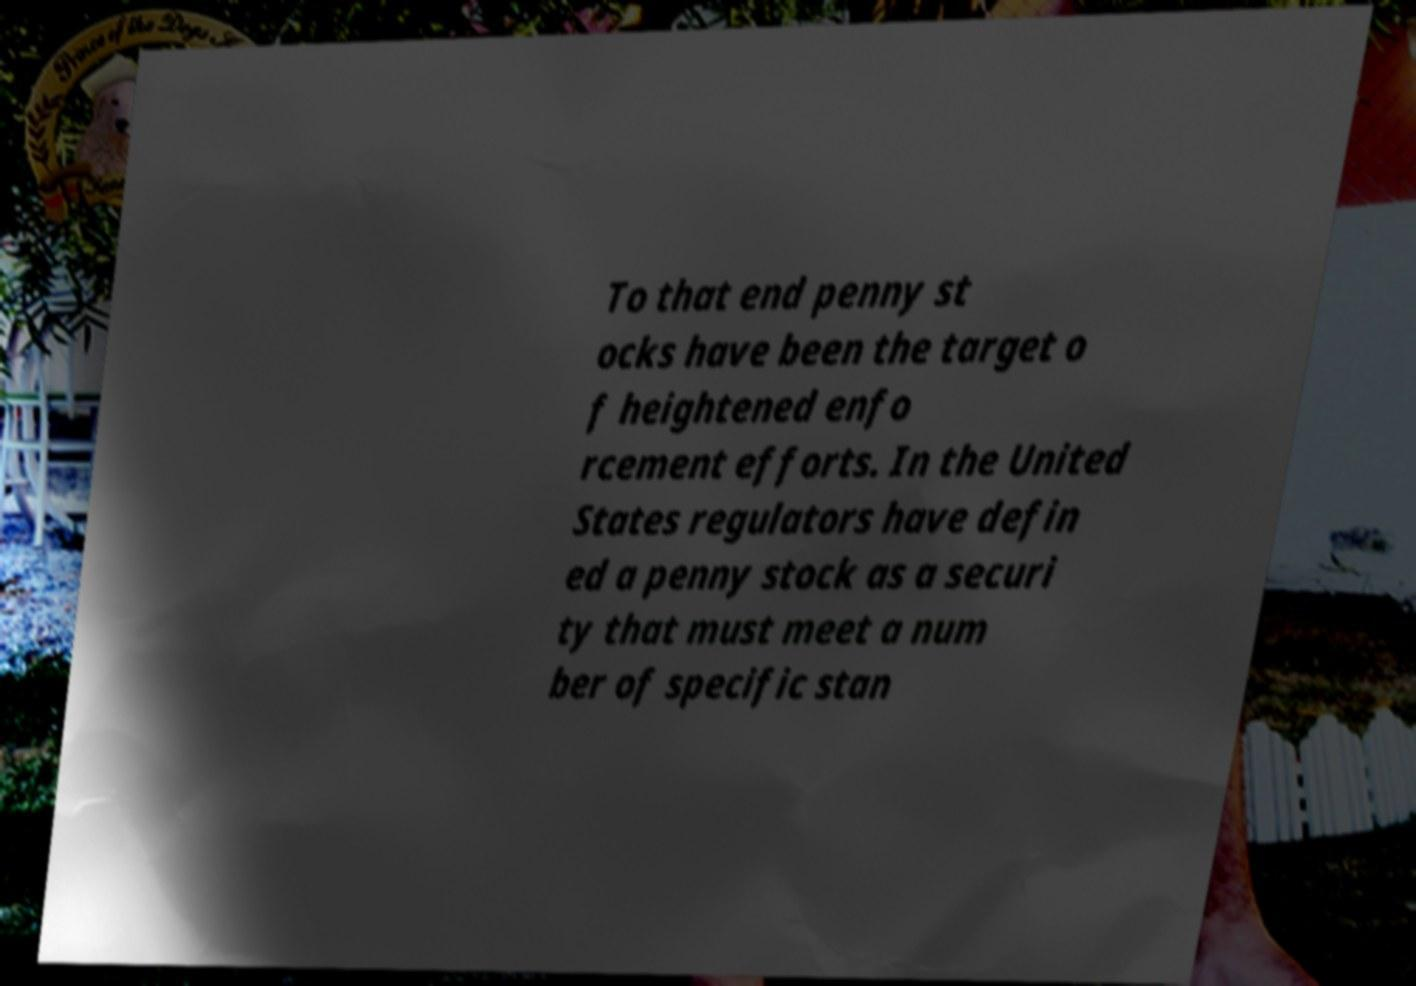Can you read and provide the text displayed in the image?This photo seems to have some interesting text. Can you extract and type it out for me? To that end penny st ocks have been the target o f heightened enfo rcement efforts. In the United States regulators have defin ed a penny stock as a securi ty that must meet a num ber of specific stan 